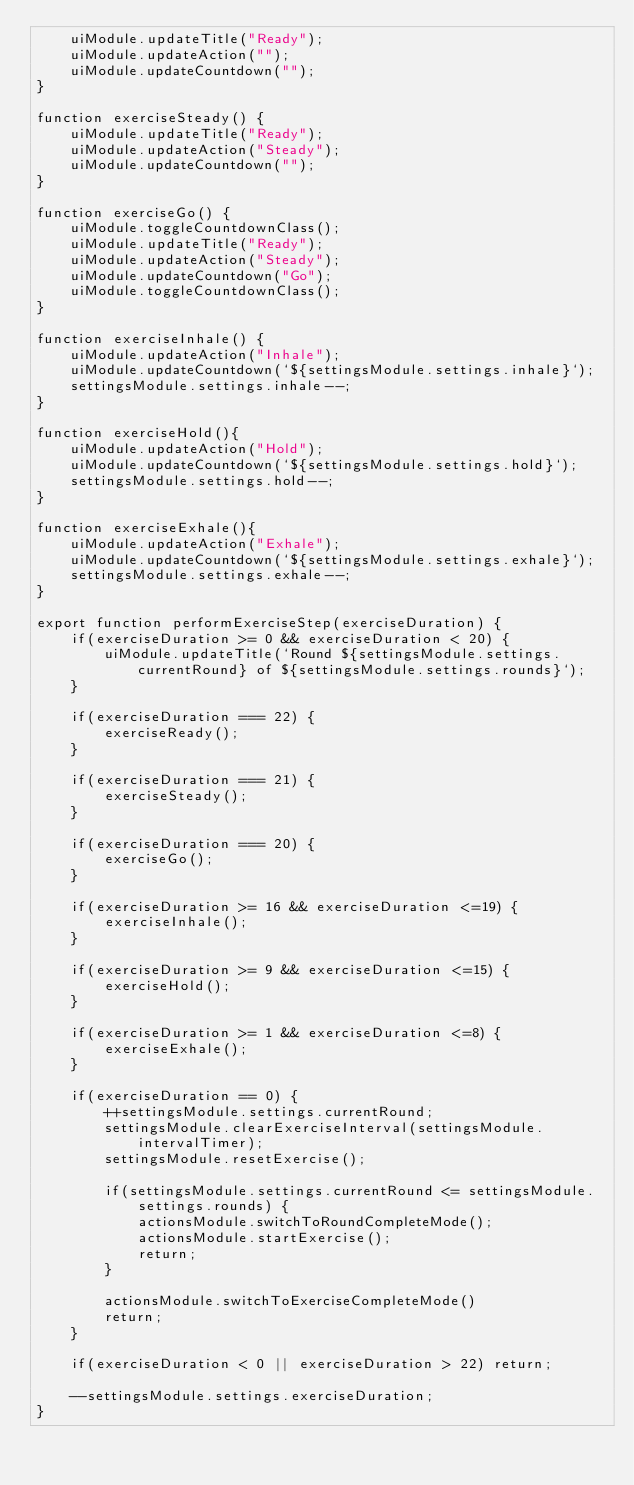Convert code to text. <code><loc_0><loc_0><loc_500><loc_500><_JavaScript_>    uiModule.updateTitle("Ready");
    uiModule.updateAction("");
    uiModule.updateCountdown("");
}

function exerciseSteady() {
    uiModule.updateTitle("Ready");
    uiModule.updateAction("Steady");
    uiModule.updateCountdown("");
}

function exerciseGo() {
    uiModule.toggleCountdownClass();
    uiModule.updateTitle("Ready");
    uiModule.updateAction("Steady");
    uiModule.updateCountdown("Go");
    uiModule.toggleCountdownClass();
}

function exerciseInhale() {
    uiModule.updateAction("Inhale");
    uiModule.updateCountdown(`${settingsModule.settings.inhale}`);
    settingsModule.settings.inhale--;
}

function exerciseHold(){
    uiModule.updateAction("Hold");
    uiModule.updateCountdown(`${settingsModule.settings.hold}`);
    settingsModule.settings.hold--;
}

function exerciseExhale(){
    uiModule.updateAction("Exhale");
    uiModule.updateCountdown(`${settingsModule.settings.exhale}`);
    settingsModule.settings.exhale--;
}

export function performExerciseStep(exerciseDuration) {
    if(exerciseDuration >= 0 && exerciseDuration < 20) {
        uiModule.updateTitle(`Round ${settingsModule.settings.currentRound} of ${settingsModule.settings.rounds}`);
    }  

    if(exerciseDuration === 22) {
        exerciseReady();
    }
    
    if(exerciseDuration === 21) {
        exerciseSteady();
    }

    if(exerciseDuration === 20) {
        exerciseGo();
    }      

    if(exerciseDuration >= 16 && exerciseDuration <=19) {
        exerciseInhale();
    }

    if(exerciseDuration >= 9 && exerciseDuration <=15) {
        exerciseHold();
    }

    if(exerciseDuration >= 1 && exerciseDuration <=8) {
        exerciseExhale();
    }        

    if(exerciseDuration == 0) {
        ++settingsModule.settings.currentRound;        
        settingsModule.clearExerciseInterval(settingsModule.intervalTimer);
        settingsModule.resetExercise();

        if(settingsModule.settings.currentRound <= settingsModule.settings.rounds) {
            actionsModule.switchToRoundCompleteMode();
            actionsModule.startExercise();
            return;
        }
        
        actionsModule.switchToExerciseCompleteMode()
        return;
    }

    if(exerciseDuration < 0 || exerciseDuration > 22) return;
    
    --settingsModule.settings.exerciseDuration;    
}
</code> 